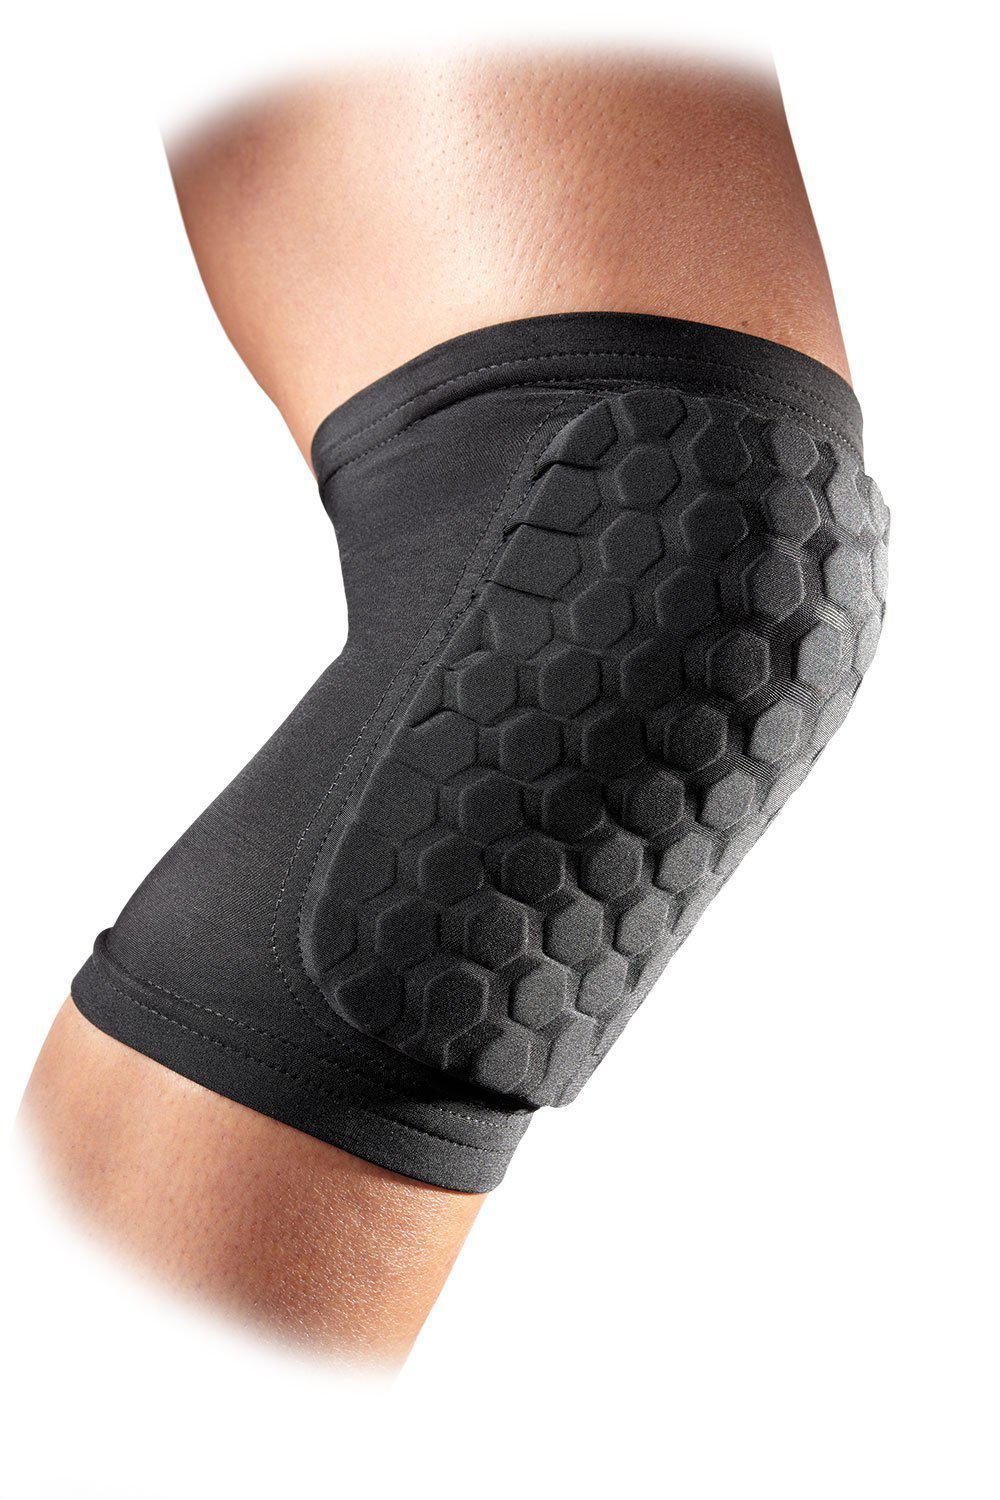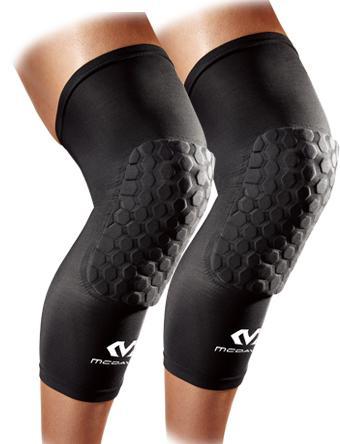The first image is the image on the left, the second image is the image on the right. Analyze the images presented: Is the assertion "There is a white knee pad next to a red knee pad" valid? Answer yes or no. No. The first image is the image on the left, the second image is the image on the right. For the images shown, is this caption "One of the images shows exactly one knee pad." true? Answer yes or no. Yes. 